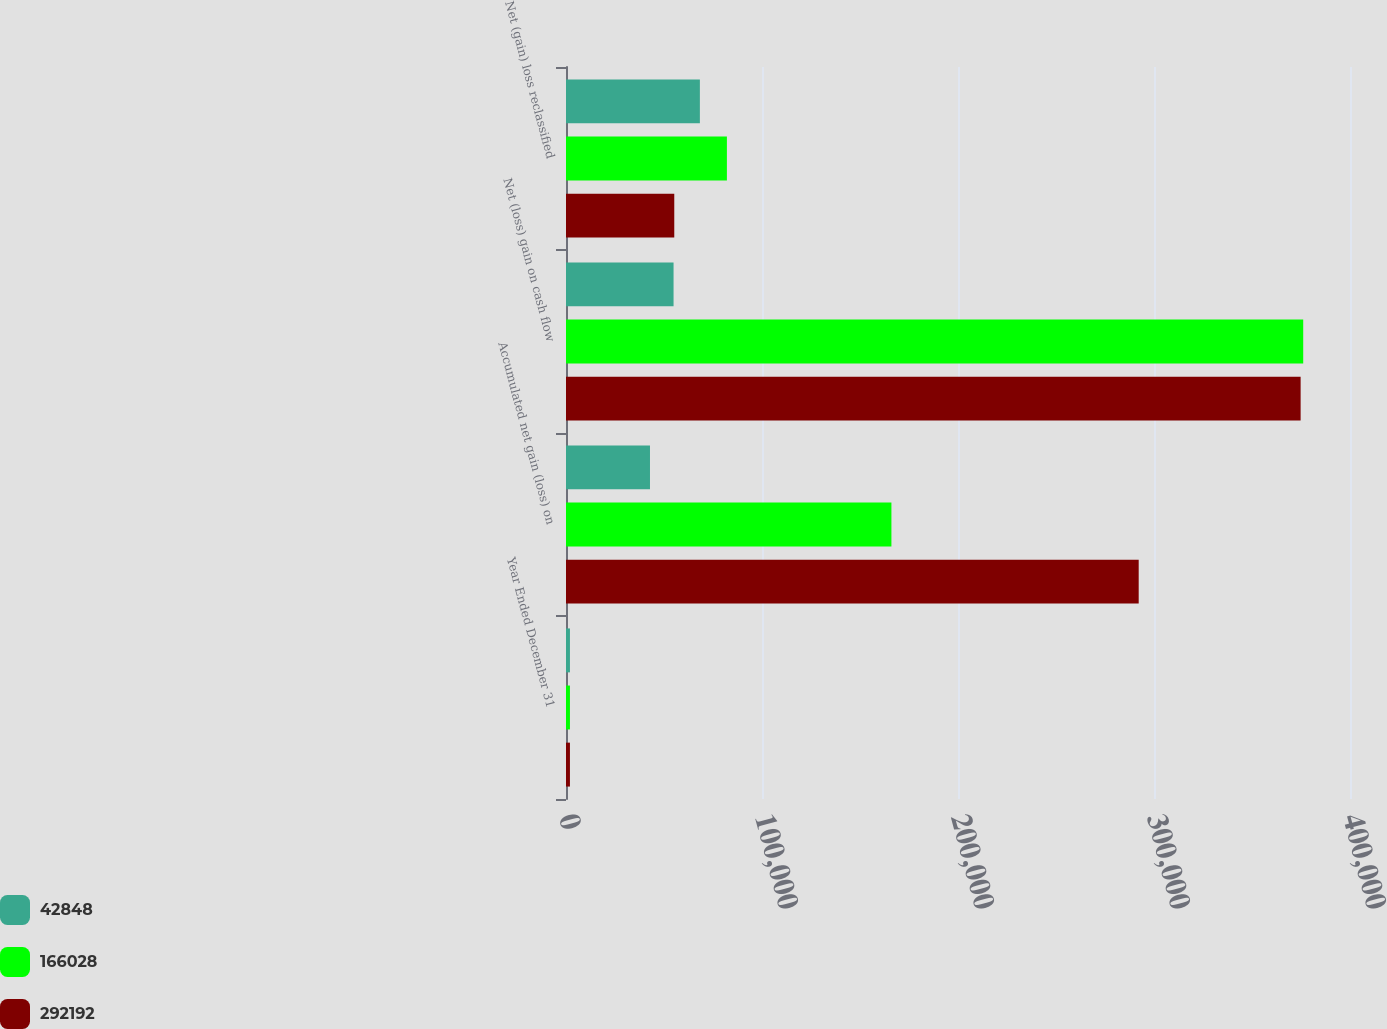<chart> <loc_0><loc_0><loc_500><loc_500><stacked_bar_chart><ecel><fcel>Year Ended December 31<fcel>Accumulated net gain (loss) on<fcel>Net (loss) gain on cash flow<fcel>Net (gain) loss reclassified<nl><fcel>42848<fcel>2010<fcel>42848<fcel>54877<fcel>68303<nl><fcel>166028<fcel>2009<fcel>166028<fcel>376128<fcel>82092<nl><fcel>292192<fcel>2008<fcel>292192<fcel>374810<fcel>55241<nl></chart> 